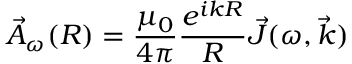<formula> <loc_0><loc_0><loc_500><loc_500>\vec { A } _ { \omega } ( R ) = \frac { \mu _ { 0 } } { 4 \pi } \frac { e ^ { i k R } } { R } \vec { J } ( \omega , \vec { k } )</formula> 